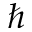<formula> <loc_0><loc_0><loc_500><loc_500>\hbar</formula> 